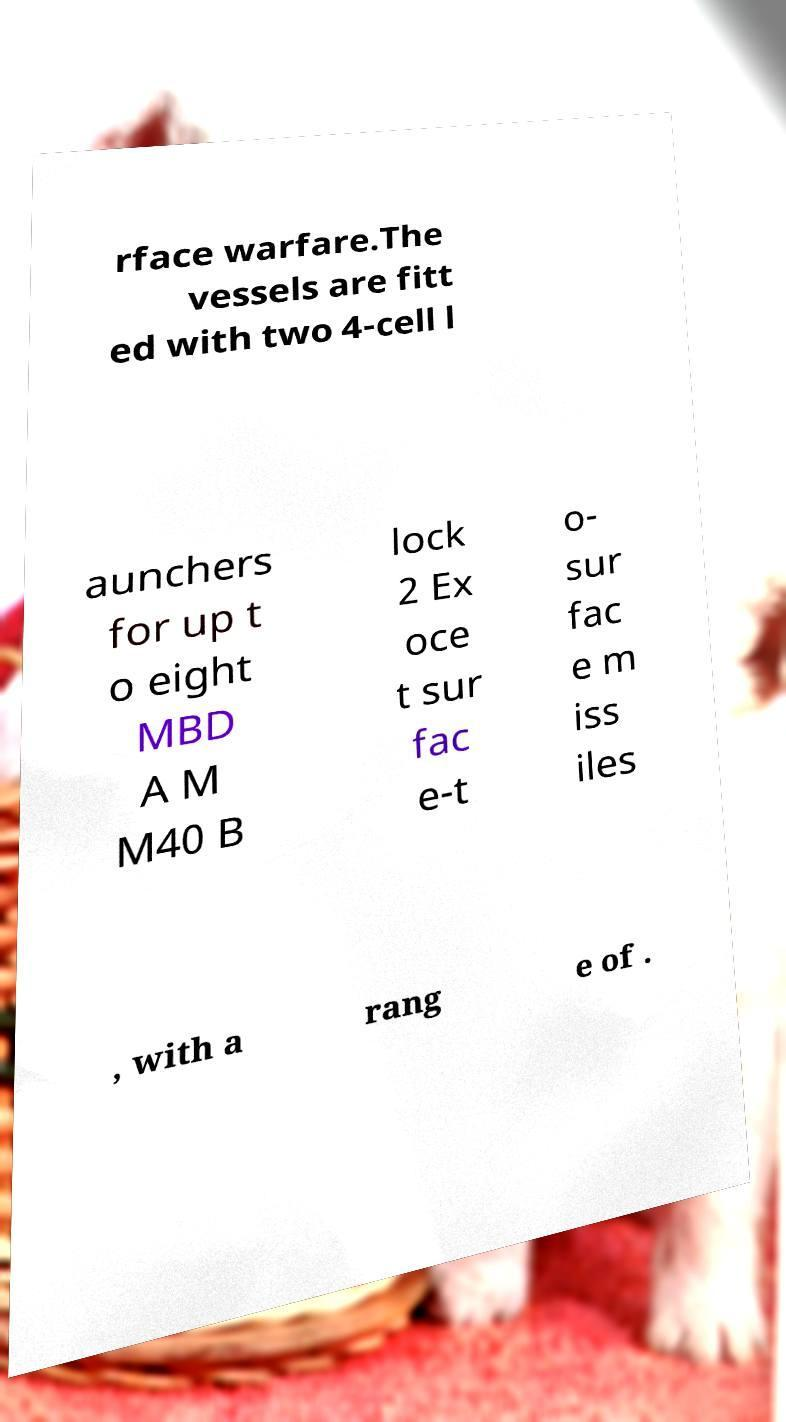Please identify and transcribe the text found in this image. rface warfare.The vessels are fitt ed with two 4-cell l aunchers for up t o eight MBD A M M40 B lock 2 Ex oce t sur fac e-t o- sur fac e m iss iles , with a rang e of . 